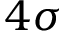Convert formula to latex. <formula><loc_0><loc_0><loc_500><loc_500>4 \sigma</formula> 